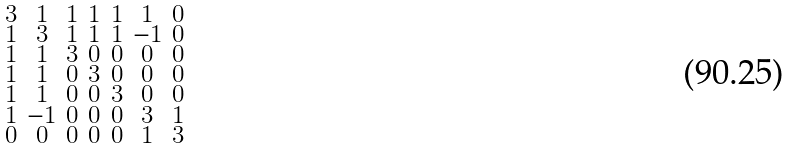<formula> <loc_0><loc_0><loc_500><loc_500>\begin{smallmatrix} 3 & 1 & 1 & 1 & 1 & 1 & 0 \\ 1 & 3 & 1 & 1 & 1 & - 1 & 0 \\ 1 & 1 & 3 & 0 & 0 & 0 & 0 \\ 1 & 1 & 0 & 3 & 0 & 0 & 0 \\ 1 & 1 & 0 & 0 & 3 & 0 & 0 \\ 1 & - 1 & 0 & 0 & 0 & 3 & 1 \\ 0 & 0 & 0 & 0 & 0 & 1 & 3 \end{smallmatrix}</formula> 